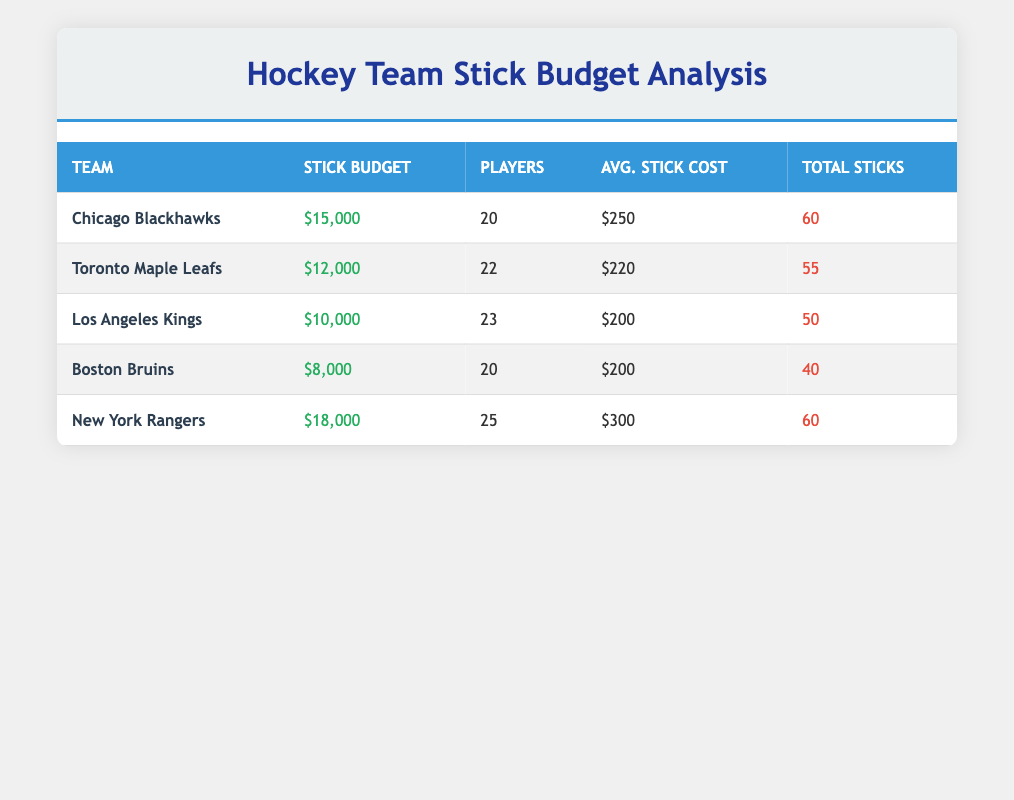What is the average budget for stick purchases across all teams? To find the average budget, sum the budgets of all teams: 15000 + 12000 + 10000 + 8000 + 18000 = 63000. Then divide by the number of teams, which is 5: 63000 / 5 = 12600.
Answer: 12600 Which team has the highest budget for sticks? Looking at the budget column, the New York Rangers have a budget of 18000, which is greater than any other team listed.
Answer: New York Rangers Is the average stick cost for the Chicago Blackhawks higher than that for the Boston Bruins? The average stick cost for the Chicago Blackhawks is 250, while it is 200 for the Boston Bruins. Since 250 is greater than 200, the answer is yes.
Answer: Yes How many more sticks did the Chicago Blackhawks purchase compared to the Los Angeles Kings? The Chicago Blackhawks purchased 60 sticks, whereas the Los Angeles Kings purchased 50. The difference is 60 - 50 = 10.
Answer: 10 If the total budget of the Toronto Maple Leafs and the Boston Bruins is combined, what is the total? The budget for Toronto Maple Leafs is 12000 and for Boston Bruins is 8000. Adding these together gives: 12000 + 8000 = 20000.
Answer: 20000 Did the teams that purchased more than 50 sticks spend more than $10,000 in total? The teams that purchased more than 50 sticks are the Chicago Blackhawks and the New York Rangers. Their budgets are 15000 and 18000, respectively, which sums to 33000, which is greater than 10000.
Answer: Yes What is the total number of players across all teams? To find the total number of players, sum the number of players for each team: 20 + 22 + 23 + 20 + 25 = 110.
Answer: 110 Which team has the lowest average stick cost? The average stick costs are 250 for Chicago Blackhawks, 220 for Toronto Maple Leafs, 200 for both Los Angeles Kings and Boston Bruins, and 300 for New York Rangers. The lowest average stick cost is 200, which pertains to both the Los Angeles Kings and Boston Bruins.
Answer: Los Angeles Kings and Boston Bruins How many sticks were purchased on average per player for the New York Rangers? For the New York Rangers, 60 sticks were purchased and they have 25 players. Dividing the total sticks by the number of players gives 60 / 25 = 2.4 sticks per player.
Answer: 2.4 